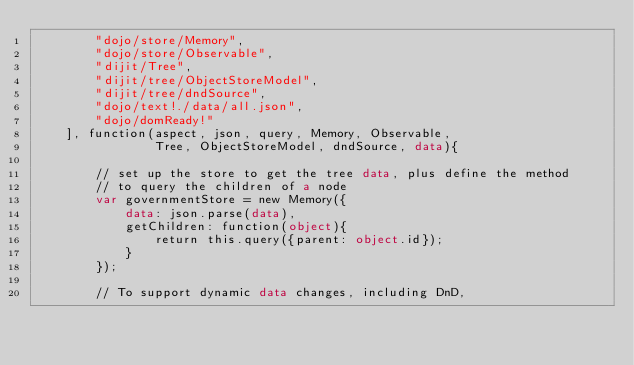Convert code to text. <code><loc_0><loc_0><loc_500><loc_500><_HTML_>		"dojo/store/Memory",
		"dojo/store/Observable",
		"dijit/Tree",
		"dijit/tree/ObjectStoreModel",
		"dijit/tree/dndSource",
		"dojo/text!./data/all.json",
		"dojo/domReady!"
	], function(aspect, json, query, Memory, Observable,
				Tree, ObjectStoreModel, dndSource, data){

		// set up the store to get the tree data, plus define the method
		// to query the children of a node
		var governmentStore = new Memory({
			data: json.parse(data),
			getChildren: function(object){
				return this.query({parent: object.id});
			}
		});

		// To support dynamic data changes, including DnD,</code> 